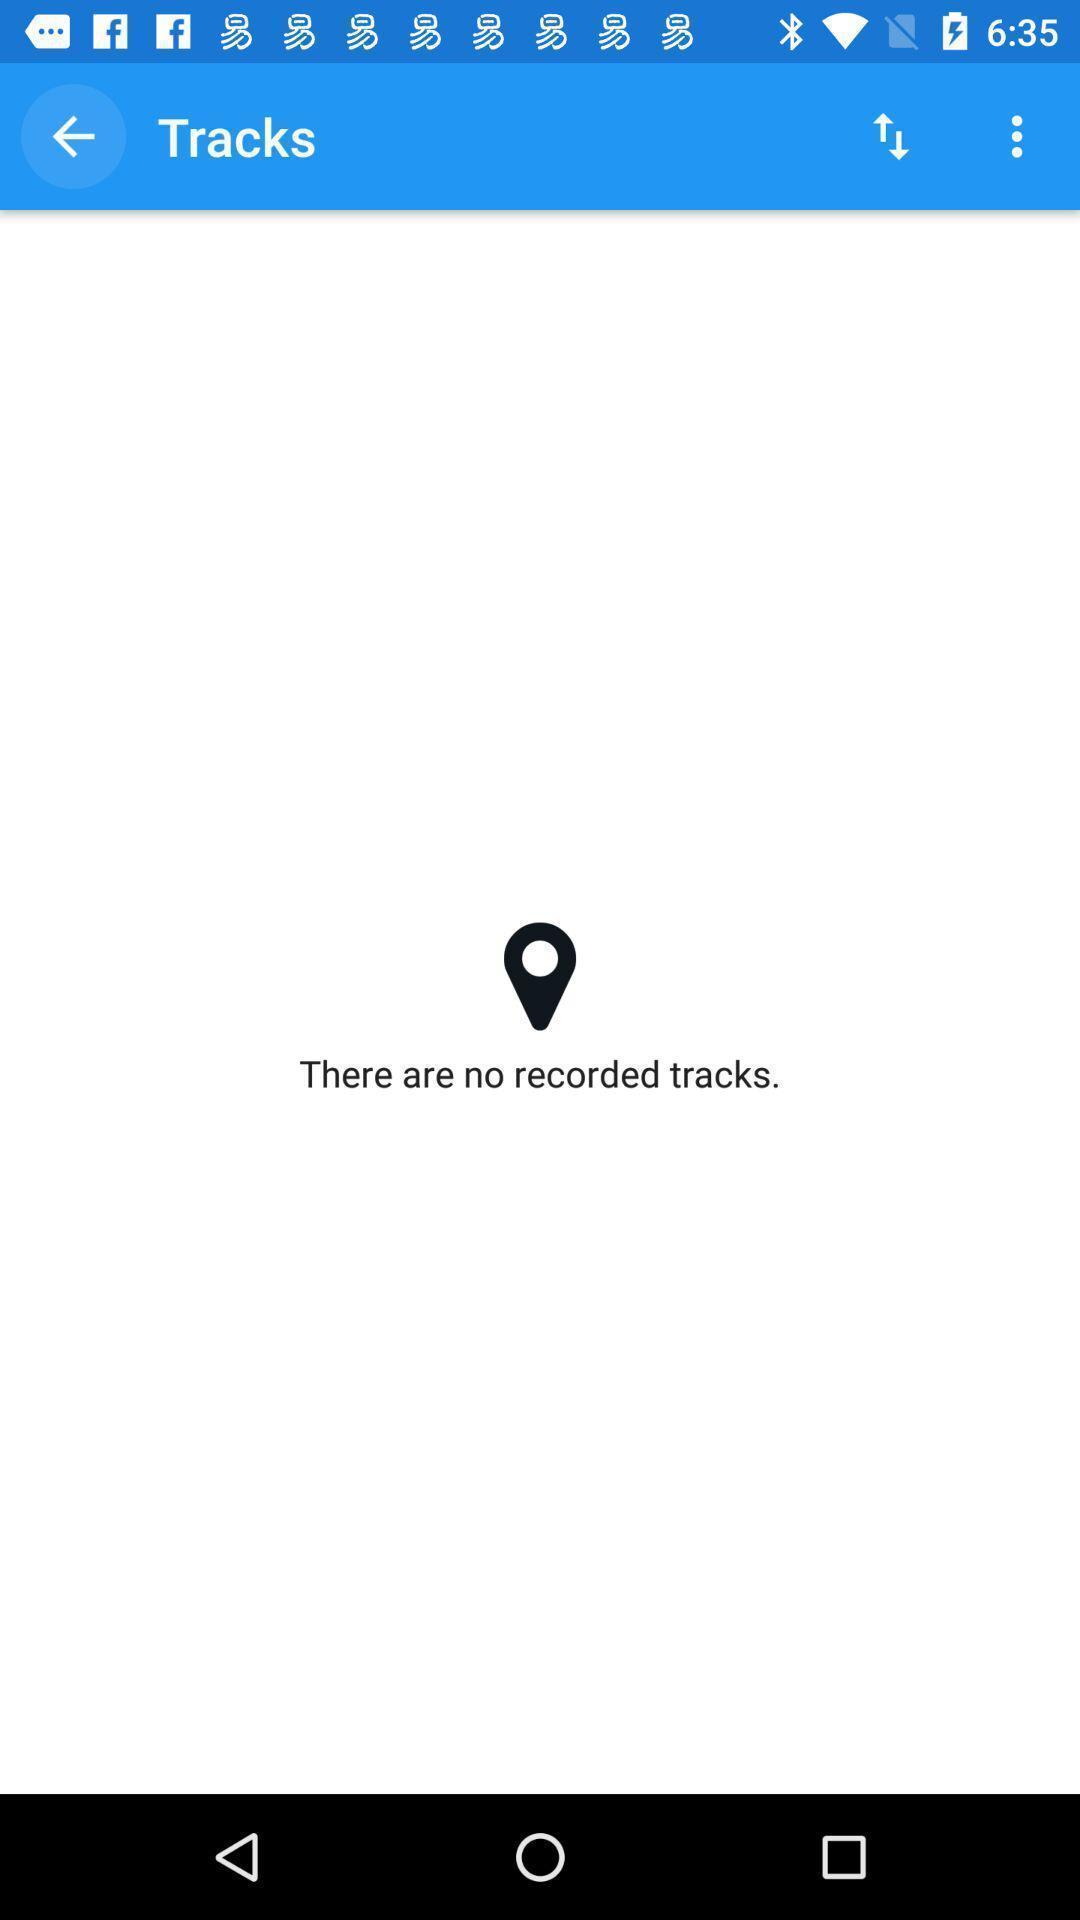Tell me what you see in this picture. Screen displaying a tracking icon. 